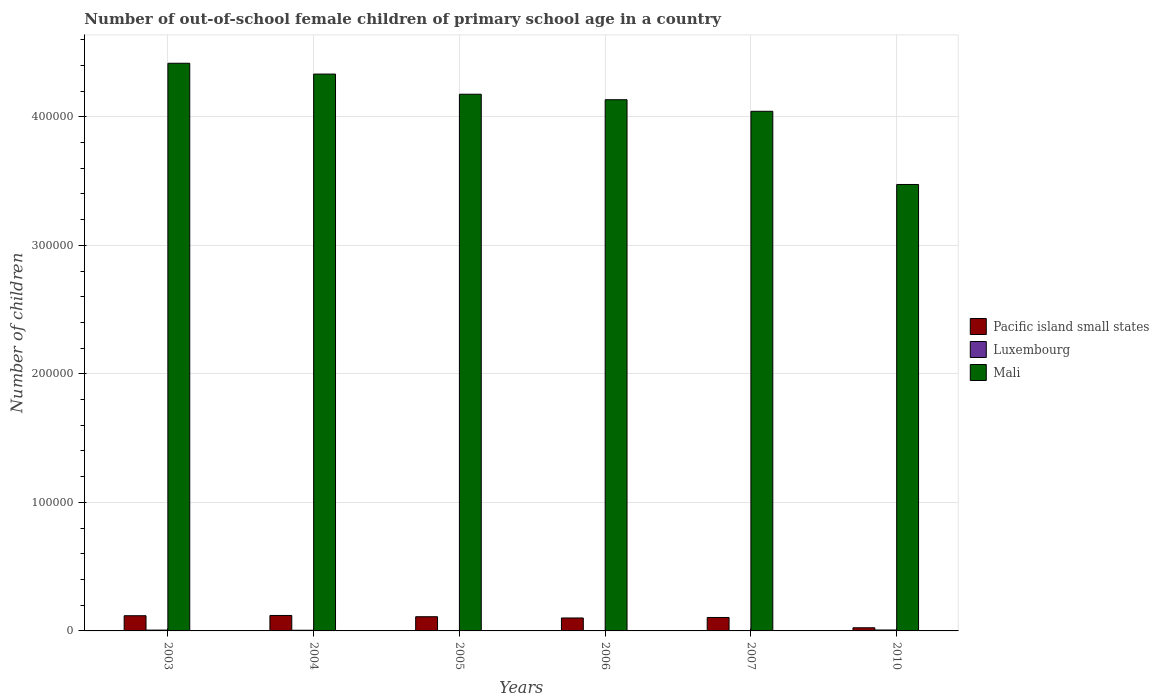How many groups of bars are there?
Make the answer very short. 6. Are the number of bars on each tick of the X-axis equal?
Offer a very short reply. Yes. How many bars are there on the 2nd tick from the left?
Give a very brief answer. 3. How many bars are there on the 2nd tick from the right?
Offer a terse response. 3. What is the label of the 2nd group of bars from the left?
Keep it short and to the point. 2004. In how many cases, is the number of bars for a given year not equal to the number of legend labels?
Keep it short and to the point. 0. What is the number of out-of-school female children in Pacific island small states in 2004?
Make the answer very short. 1.20e+04. Across all years, what is the maximum number of out-of-school female children in Mali?
Offer a terse response. 4.42e+05. Across all years, what is the minimum number of out-of-school female children in Pacific island small states?
Your response must be concise. 2454. In which year was the number of out-of-school female children in Pacific island small states minimum?
Keep it short and to the point. 2010. What is the total number of out-of-school female children in Luxembourg in the graph?
Offer a very short reply. 2594. What is the difference between the number of out-of-school female children in Luxembourg in 2004 and that in 2005?
Your response must be concise. 237. What is the difference between the number of out-of-school female children in Pacific island small states in 2010 and the number of out-of-school female children in Mali in 2003?
Make the answer very short. -4.39e+05. What is the average number of out-of-school female children in Mali per year?
Provide a short and direct response. 4.10e+05. In the year 2003, what is the difference between the number of out-of-school female children in Mali and number of out-of-school female children in Pacific island small states?
Provide a short and direct response. 4.30e+05. In how many years, is the number of out-of-school female children in Pacific island small states greater than 280000?
Your answer should be very brief. 0. What is the ratio of the number of out-of-school female children in Luxembourg in 2004 to that in 2006?
Make the answer very short. 2.59. Is the number of out-of-school female children in Pacific island small states in 2003 less than that in 2006?
Make the answer very short. No. What is the difference between the highest and the second highest number of out-of-school female children in Mali?
Provide a short and direct response. 8409. What is the difference between the highest and the lowest number of out-of-school female children in Luxembourg?
Your answer should be compact. 523. What does the 1st bar from the left in 2007 represents?
Offer a very short reply. Pacific island small states. What does the 3rd bar from the right in 2007 represents?
Give a very brief answer. Pacific island small states. Is it the case that in every year, the sum of the number of out-of-school female children in Luxembourg and number of out-of-school female children in Mali is greater than the number of out-of-school female children in Pacific island small states?
Provide a short and direct response. Yes. How many bars are there?
Your response must be concise. 18. How many years are there in the graph?
Keep it short and to the point. 6. Does the graph contain any zero values?
Your answer should be very brief. No. Where does the legend appear in the graph?
Offer a terse response. Center right. How are the legend labels stacked?
Give a very brief answer. Vertical. What is the title of the graph?
Provide a short and direct response. Number of out-of-school female children of primary school age in a country. What is the label or title of the X-axis?
Your answer should be compact. Years. What is the label or title of the Y-axis?
Keep it short and to the point. Number of children. What is the Number of children in Pacific island small states in 2003?
Keep it short and to the point. 1.18e+04. What is the Number of children of Luxembourg in 2003?
Provide a short and direct response. 639. What is the Number of children of Mali in 2003?
Your response must be concise. 4.42e+05. What is the Number of children in Pacific island small states in 2004?
Offer a very short reply. 1.20e+04. What is the Number of children in Luxembourg in 2004?
Your answer should be very brief. 521. What is the Number of children of Mali in 2004?
Offer a very short reply. 4.33e+05. What is the Number of children of Pacific island small states in 2005?
Offer a terse response. 1.10e+04. What is the Number of children of Luxembourg in 2005?
Your answer should be compact. 284. What is the Number of children of Mali in 2005?
Ensure brevity in your answer.  4.18e+05. What is the Number of children of Pacific island small states in 2006?
Make the answer very short. 1.01e+04. What is the Number of children of Luxembourg in 2006?
Offer a very short reply. 201. What is the Number of children of Mali in 2006?
Provide a succinct answer. 4.13e+05. What is the Number of children in Pacific island small states in 2007?
Your response must be concise. 1.05e+04. What is the Number of children of Luxembourg in 2007?
Give a very brief answer. 225. What is the Number of children in Mali in 2007?
Your answer should be compact. 4.04e+05. What is the Number of children in Pacific island small states in 2010?
Provide a succinct answer. 2454. What is the Number of children of Luxembourg in 2010?
Your answer should be very brief. 724. What is the Number of children of Mali in 2010?
Ensure brevity in your answer.  3.47e+05. Across all years, what is the maximum Number of children of Pacific island small states?
Make the answer very short. 1.20e+04. Across all years, what is the maximum Number of children of Luxembourg?
Ensure brevity in your answer.  724. Across all years, what is the maximum Number of children of Mali?
Ensure brevity in your answer.  4.42e+05. Across all years, what is the minimum Number of children in Pacific island small states?
Keep it short and to the point. 2454. Across all years, what is the minimum Number of children in Luxembourg?
Ensure brevity in your answer.  201. Across all years, what is the minimum Number of children of Mali?
Keep it short and to the point. 3.47e+05. What is the total Number of children in Pacific island small states in the graph?
Offer a very short reply. 5.79e+04. What is the total Number of children in Luxembourg in the graph?
Your answer should be compact. 2594. What is the total Number of children in Mali in the graph?
Your answer should be compact. 2.46e+06. What is the difference between the Number of children of Pacific island small states in 2003 and that in 2004?
Keep it short and to the point. -208. What is the difference between the Number of children of Luxembourg in 2003 and that in 2004?
Offer a terse response. 118. What is the difference between the Number of children of Mali in 2003 and that in 2004?
Keep it short and to the point. 8409. What is the difference between the Number of children of Pacific island small states in 2003 and that in 2005?
Offer a terse response. 770. What is the difference between the Number of children of Luxembourg in 2003 and that in 2005?
Keep it short and to the point. 355. What is the difference between the Number of children of Mali in 2003 and that in 2005?
Your answer should be very brief. 2.41e+04. What is the difference between the Number of children of Pacific island small states in 2003 and that in 2006?
Your answer should be compact. 1746. What is the difference between the Number of children of Luxembourg in 2003 and that in 2006?
Offer a terse response. 438. What is the difference between the Number of children in Mali in 2003 and that in 2006?
Keep it short and to the point. 2.84e+04. What is the difference between the Number of children in Pacific island small states in 2003 and that in 2007?
Offer a terse response. 1361. What is the difference between the Number of children in Luxembourg in 2003 and that in 2007?
Provide a succinct answer. 414. What is the difference between the Number of children in Mali in 2003 and that in 2007?
Make the answer very short. 3.74e+04. What is the difference between the Number of children in Pacific island small states in 2003 and that in 2010?
Keep it short and to the point. 9364. What is the difference between the Number of children in Luxembourg in 2003 and that in 2010?
Your response must be concise. -85. What is the difference between the Number of children in Mali in 2003 and that in 2010?
Your answer should be very brief. 9.43e+04. What is the difference between the Number of children of Pacific island small states in 2004 and that in 2005?
Give a very brief answer. 978. What is the difference between the Number of children of Luxembourg in 2004 and that in 2005?
Give a very brief answer. 237. What is the difference between the Number of children in Mali in 2004 and that in 2005?
Keep it short and to the point. 1.57e+04. What is the difference between the Number of children of Pacific island small states in 2004 and that in 2006?
Your answer should be very brief. 1954. What is the difference between the Number of children of Luxembourg in 2004 and that in 2006?
Offer a terse response. 320. What is the difference between the Number of children of Mali in 2004 and that in 2006?
Give a very brief answer. 2.00e+04. What is the difference between the Number of children of Pacific island small states in 2004 and that in 2007?
Keep it short and to the point. 1569. What is the difference between the Number of children of Luxembourg in 2004 and that in 2007?
Your answer should be compact. 296. What is the difference between the Number of children of Mali in 2004 and that in 2007?
Your answer should be compact. 2.90e+04. What is the difference between the Number of children of Pacific island small states in 2004 and that in 2010?
Provide a short and direct response. 9572. What is the difference between the Number of children in Luxembourg in 2004 and that in 2010?
Offer a very short reply. -203. What is the difference between the Number of children of Mali in 2004 and that in 2010?
Keep it short and to the point. 8.59e+04. What is the difference between the Number of children of Pacific island small states in 2005 and that in 2006?
Offer a very short reply. 976. What is the difference between the Number of children of Mali in 2005 and that in 2006?
Make the answer very short. 4285. What is the difference between the Number of children in Pacific island small states in 2005 and that in 2007?
Offer a terse response. 591. What is the difference between the Number of children of Luxembourg in 2005 and that in 2007?
Offer a terse response. 59. What is the difference between the Number of children in Mali in 2005 and that in 2007?
Your answer should be very brief. 1.33e+04. What is the difference between the Number of children in Pacific island small states in 2005 and that in 2010?
Your answer should be compact. 8594. What is the difference between the Number of children in Luxembourg in 2005 and that in 2010?
Offer a very short reply. -440. What is the difference between the Number of children of Mali in 2005 and that in 2010?
Your answer should be compact. 7.02e+04. What is the difference between the Number of children in Pacific island small states in 2006 and that in 2007?
Offer a terse response. -385. What is the difference between the Number of children of Mali in 2006 and that in 2007?
Your answer should be very brief. 8988. What is the difference between the Number of children in Pacific island small states in 2006 and that in 2010?
Make the answer very short. 7618. What is the difference between the Number of children in Luxembourg in 2006 and that in 2010?
Offer a terse response. -523. What is the difference between the Number of children of Mali in 2006 and that in 2010?
Your answer should be compact. 6.59e+04. What is the difference between the Number of children in Pacific island small states in 2007 and that in 2010?
Ensure brevity in your answer.  8003. What is the difference between the Number of children of Luxembourg in 2007 and that in 2010?
Offer a terse response. -499. What is the difference between the Number of children of Mali in 2007 and that in 2010?
Offer a very short reply. 5.69e+04. What is the difference between the Number of children of Pacific island small states in 2003 and the Number of children of Luxembourg in 2004?
Your response must be concise. 1.13e+04. What is the difference between the Number of children of Pacific island small states in 2003 and the Number of children of Mali in 2004?
Provide a succinct answer. -4.21e+05. What is the difference between the Number of children in Luxembourg in 2003 and the Number of children in Mali in 2004?
Ensure brevity in your answer.  -4.33e+05. What is the difference between the Number of children in Pacific island small states in 2003 and the Number of children in Luxembourg in 2005?
Ensure brevity in your answer.  1.15e+04. What is the difference between the Number of children in Pacific island small states in 2003 and the Number of children in Mali in 2005?
Your response must be concise. -4.06e+05. What is the difference between the Number of children of Luxembourg in 2003 and the Number of children of Mali in 2005?
Your response must be concise. -4.17e+05. What is the difference between the Number of children in Pacific island small states in 2003 and the Number of children in Luxembourg in 2006?
Offer a terse response. 1.16e+04. What is the difference between the Number of children in Pacific island small states in 2003 and the Number of children in Mali in 2006?
Ensure brevity in your answer.  -4.01e+05. What is the difference between the Number of children of Luxembourg in 2003 and the Number of children of Mali in 2006?
Provide a short and direct response. -4.13e+05. What is the difference between the Number of children in Pacific island small states in 2003 and the Number of children in Luxembourg in 2007?
Offer a terse response. 1.16e+04. What is the difference between the Number of children of Pacific island small states in 2003 and the Number of children of Mali in 2007?
Your response must be concise. -3.92e+05. What is the difference between the Number of children of Luxembourg in 2003 and the Number of children of Mali in 2007?
Offer a very short reply. -4.04e+05. What is the difference between the Number of children in Pacific island small states in 2003 and the Number of children in Luxembourg in 2010?
Offer a very short reply. 1.11e+04. What is the difference between the Number of children in Pacific island small states in 2003 and the Number of children in Mali in 2010?
Your response must be concise. -3.36e+05. What is the difference between the Number of children of Luxembourg in 2003 and the Number of children of Mali in 2010?
Keep it short and to the point. -3.47e+05. What is the difference between the Number of children of Pacific island small states in 2004 and the Number of children of Luxembourg in 2005?
Your answer should be very brief. 1.17e+04. What is the difference between the Number of children in Pacific island small states in 2004 and the Number of children in Mali in 2005?
Give a very brief answer. -4.06e+05. What is the difference between the Number of children in Luxembourg in 2004 and the Number of children in Mali in 2005?
Offer a terse response. -4.17e+05. What is the difference between the Number of children of Pacific island small states in 2004 and the Number of children of Luxembourg in 2006?
Keep it short and to the point. 1.18e+04. What is the difference between the Number of children of Pacific island small states in 2004 and the Number of children of Mali in 2006?
Ensure brevity in your answer.  -4.01e+05. What is the difference between the Number of children of Luxembourg in 2004 and the Number of children of Mali in 2006?
Give a very brief answer. -4.13e+05. What is the difference between the Number of children of Pacific island small states in 2004 and the Number of children of Luxembourg in 2007?
Give a very brief answer. 1.18e+04. What is the difference between the Number of children in Pacific island small states in 2004 and the Number of children in Mali in 2007?
Provide a short and direct response. -3.92e+05. What is the difference between the Number of children in Luxembourg in 2004 and the Number of children in Mali in 2007?
Ensure brevity in your answer.  -4.04e+05. What is the difference between the Number of children in Pacific island small states in 2004 and the Number of children in Luxembourg in 2010?
Ensure brevity in your answer.  1.13e+04. What is the difference between the Number of children in Pacific island small states in 2004 and the Number of children in Mali in 2010?
Provide a short and direct response. -3.35e+05. What is the difference between the Number of children of Luxembourg in 2004 and the Number of children of Mali in 2010?
Give a very brief answer. -3.47e+05. What is the difference between the Number of children of Pacific island small states in 2005 and the Number of children of Luxembourg in 2006?
Make the answer very short. 1.08e+04. What is the difference between the Number of children of Pacific island small states in 2005 and the Number of children of Mali in 2006?
Provide a short and direct response. -4.02e+05. What is the difference between the Number of children in Luxembourg in 2005 and the Number of children in Mali in 2006?
Provide a succinct answer. -4.13e+05. What is the difference between the Number of children in Pacific island small states in 2005 and the Number of children in Luxembourg in 2007?
Your response must be concise. 1.08e+04. What is the difference between the Number of children in Pacific island small states in 2005 and the Number of children in Mali in 2007?
Your answer should be compact. -3.93e+05. What is the difference between the Number of children of Luxembourg in 2005 and the Number of children of Mali in 2007?
Ensure brevity in your answer.  -4.04e+05. What is the difference between the Number of children of Pacific island small states in 2005 and the Number of children of Luxembourg in 2010?
Your response must be concise. 1.03e+04. What is the difference between the Number of children of Pacific island small states in 2005 and the Number of children of Mali in 2010?
Offer a terse response. -3.36e+05. What is the difference between the Number of children in Luxembourg in 2005 and the Number of children in Mali in 2010?
Keep it short and to the point. -3.47e+05. What is the difference between the Number of children in Pacific island small states in 2006 and the Number of children in Luxembourg in 2007?
Provide a short and direct response. 9847. What is the difference between the Number of children of Pacific island small states in 2006 and the Number of children of Mali in 2007?
Your answer should be very brief. -3.94e+05. What is the difference between the Number of children in Luxembourg in 2006 and the Number of children in Mali in 2007?
Keep it short and to the point. -4.04e+05. What is the difference between the Number of children in Pacific island small states in 2006 and the Number of children in Luxembourg in 2010?
Make the answer very short. 9348. What is the difference between the Number of children of Pacific island small states in 2006 and the Number of children of Mali in 2010?
Your answer should be compact. -3.37e+05. What is the difference between the Number of children in Luxembourg in 2006 and the Number of children in Mali in 2010?
Make the answer very short. -3.47e+05. What is the difference between the Number of children of Pacific island small states in 2007 and the Number of children of Luxembourg in 2010?
Provide a short and direct response. 9733. What is the difference between the Number of children in Pacific island small states in 2007 and the Number of children in Mali in 2010?
Make the answer very short. -3.37e+05. What is the difference between the Number of children of Luxembourg in 2007 and the Number of children of Mali in 2010?
Make the answer very short. -3.47e+05. What is the average Number of children of Pacific island small states per year?
Ensure brevity in your answer.  9645.83. What is the average Number of children of Luxembourg per year?
Ensure brevity in your answer.  432.33. What is the average Number of children in Mali per year?
Give a very brief answer. 4.10e+05. In the year 2003, what is the difference between the Number of children in Pacific island small states and Number of children in Luxembourg?
Provide a succinct answer. 1.12e+04. In the year 2003, what is the difference between the Number of children of Pacific island small states and Number of children of Mali?
Make the answer very short. -4.30e+05. In the year 2003, what is the difference between the Number of children in Luxembourg and Number of children in Mali?
Make the answer very short. -4.41e+05. In the year 2004, what is the difference between the Number of children in Pacific island small states and Number of children in Luxembourg?
Give a very brief answer. 1.15e+04. In the year 2004, what is the difference between the Number of children of Pacific island small states and Number of children of Mali?
Your response must be concise. -4.21e+05. In the year 2004, what is the difference between the Number of children in Luxembourg and Number of children in Mali?
Offer a terse response. -4.33e+05. In the year 2005, what is the difference between the Number of children of Pacific island small states and Number of children of Luxembourg?
Give a very brief answer. 1.08e+04. In the year 2005, what is the difference between the Number of children in Pacific island small states and Number of children in Mali?
Offer a very short reply. -4.06e+05. In the year 2005, what is the difference between the Number of children of Luxembourg and Number of children of Mali?
Provide a succinct answer. -4.17e+05. In the year 2006, what is the difference between the Number of children in Pacific island small states and Number of children in Luxembourg?
Your answer should be very brief. 9871. In the year 2006, what is the difference between the Number of children in Pacific island small states and Number of children in Mali?
Ensure brevity in your answer.  -4.03e+05. In the year 2006, what is the difference between the Number of children in Luxembourg and Number of children in Mali?
Your answer should be very brief. -4.13e+05. In the year 2007, what is the difference between the Number of children in Pacific island small states and Number of children in Luxembourg?
Provide a short and direct response. 1.02e+04. In the year 2007, what is the difference between the Number of children in Pacific island small states and Number of children in Mali?
Provide a short and direct response. -3.94e+05. In the year 2007, what is the difference between the Number of children of Luxembourg and Number of children of Mali?
Your response must be concise. -4.04e+05. In the year 2010, what is the difference between the Number of children of Pacific island small states and Number of children of Luxembourg?
Offer a terse response. 1730. In the year 2010, what is the difference between the Number of children in Pacific island small states and Number of children in Mali?
Offer a very short reply. -3.45e+05. In the year 2010, what is the difference between the Number of children of Luxembourg and Number of children of Mali?
Your answer should be compact. -3.47e+05. What is the ratio of the Number of children in Pacific island small states in 2003 to that in 2004?
Keep it short and to the point. 0.98. What is the ratio of the Number of children in Luxembourg in 2003 to that in 2004?
Ensure brevity in your answer.  1.23. What is the ratio of the Number of children of Mali in 2003 to that in 2004?
Offer a very short reply. 1.02. What is the ratio of the Number of children of Pacific island small states in 2003 to that in 2005?
Provide a succinct answer. 1.07. What is the ratio of the Number of children of Luxembourg in 2003 to that in 2005?
Provide a short and direct response. 2.25. What is the ratio of the Number of children of Mali in 2003 to that in 2005?
Give a very brief answer. 1.06. What is the ratio of the Number of children in Pacific island small states in 2003 to that in 2006?
Give a very brief answer. 1.17. What is the ratio of the Number of children of Luxembourg in 2003 to that in 2006?
Keep it short and to the point. 3.18. What is the ratio of the Number of children in Mali in 2003 to that in 2006?
Your answer should be very brief. 1.07. What is the ratio of the Number of children of Pacific island small states in 2003 to that in 2007?
Your answer should be very brief. 1.13. What is the ratio of the Number of children of Luxembourg in 2003 to that in 2007?
Provide a short and direct response. 2.84. What is the ratio of the Number of children in Mali in 2003 to that in 2007?
Make the answer very short. 1.09. What is the ratio of the Number of children of Pacific island small states in 2003 to that in 2010?
Keep it short and to the point. 4.82. What is the ratio of the Number of children in Luxembourg in 2003 to that in 2010?
Your response must be concise. 0.88. What is the ratio of the Number of children in Mali in 2003 to that in 2010?
Make the answer very short. 1.27. What is the ratio of the Number of children of Pacific island small states in 2004 to that in 2005?
Ensure brevity in your answer.  1.09. What is the ratio of the Number of children in Luxembourg in 2004 to that in 2005?
Keep it short and to the point. 1.83. What is the ratio of the Number of children in Mali in 2004 to that in 2005?
Your answer should be very brief. 1.04. What is the ratio of the Number of children of Pacific island small states in 2004 to that in 2006?
Ensure brevity in your answer.  1.19. What is the ratio of the Number of children in Luxembourg in 2004 to that in 2006?
Ensure brevity in your answer.  2.59. What is the ratio of the Number of children in Mali in 2004 to that in 2006?
Make the answer very short. 1.05. What is the ratio of the Number of children in Pacific island small states in 2004 to that in 2007?
Keep it short and to the point. 1.15. What is the ratio of the Number of children in Luxembourg in 2004 to that in 2007?
Your answer should be compact. 2.32. What is the ratio of the Number of children of Mali in 2004 to that in 2007?
Your response must be concise. 1.07. What is the ratio of the Number of children of Pacific island small states in 2004 to that in 2010?
Ensure brevity in your answer.  4.9. What is the ratio of the Number of children of Luxembourg in 2004 to that in 2010?
Your answer should be compact. 0.72. What is the ratio of the Number of children of Mali in 2004 to that in 2010?
Provide a succinct answer. 1.25. What is the ratio of the Number of children in Pacific island small states in 2005 to that in 2006?
Your answer should be very brief. 1.1. What is the ratio of the Number of children of Luxembourg in 2005 to that in 2006?
Keep it short and to the point. 1.41. What is the ratio of the Number of children in Mali in 2005 to that in 2006?
Your answer should be compact. 1.01. What is the ratio of the Number of children in Pacific island small states in 2005 to that in 2007?
Provide a succinct answer. 1.06. What is the ratio of the Number of children of Luxembourg in 2005 to that in 2007?
Give a very brief answer. 1.26. What is the ratio of the Number of children in Mali in 2005 to that in 2007?
Provide a succinct answer. 1.03. What is the ratio of the Number of children in Pacific island small states in 2005 to that in 2010?
Provide a short and direct response. 4.5. What is the ratio of the Number of children of Luxembourg in 2005 to that in 2010?
Your response must be concise. 0.39. What is the ratio of the Number of children of Mali in 2005 to that in 2010?
Ensure brevity in your answer.  1.2. What is the ratio of the Number of children of Pacific island small states in 2006 to that in 2007?
Make the answer very short. 0.96. What is the ratio of the Number of children in Luxembourg in 2006 to that in 2007?
Offer a very short reply. 0.89. What is the ratio of the Number of children of Mali in 2006 to that in 2007?
Give a very brief answer. 1.02. What is the ratio of the Number of children in Pacific island small states in 2006 to that in 2010?
Offer a terse response. 4.1. What is the ratio of the Number of children in Luxembourg in 2006 to that in 2010?
Your response must be concise. 0.28. What is the ratio of the Number of children in Mali in 2006 to that in 2010?
Ensure brevity in your answer.  1.19. What is the ratio of the Number of children of Pacific island small states in 2007 to that in 2010?
Your response must be concise. 4.26. What is the ratio of the Number of children in Luxembourg in 2007 to that in 2010?
Give a very brief answer. 0.31. What is the ratio of the Number of children in Mali in 2007 to that in 2010?
Your response must be concise. 1.16. What is the difference between the highest and the second highest Number of children in Pacific island small states?
Offer a terse response. 208. What is the difference between the highest and the second highest Number of children of Luxembourg?
Provide a short and direct response. 85. What is the difference between the highest and the second highest Number of children in Mali?
Your answer should be very brief. 8409. What is the difference between the highest and the lowest Number of children of Pacific island small states?
Offer a terse response. 9572. What is the difference between the highest and the lowest Number of children in Luxembourg?
Your answer should be very brief. 523. What is the difference between the highest and the lowest Number of children in Mali?
Provide a succinct answer. 9.43e+04. 